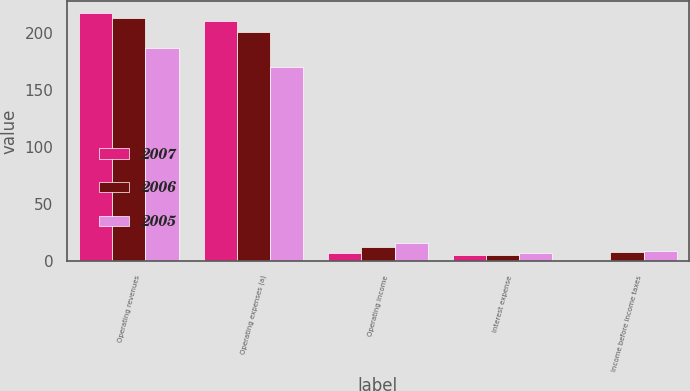Convert chart to OTSL. <chart><loc_0><loc_0><loc_500><loc_500><stacked_bar_chart><ecel><fcel>Operating revenues<fcel>Operating expenses (a)<fcel>Operating income<fcel>Interest expense<fcel>Income before income taxes<nl><fcel>2007<fcel>218<fcel>211<fcel>7<fcel>6<fcel>1<nl><fcel>2006<fcel>214<fcel>201<fcel>13<fcel>6<fcel>8<nl><fcel>2005<fcel>187<fcel>171<fcel>16<fcel>7<fcel>9<nl></chart> 